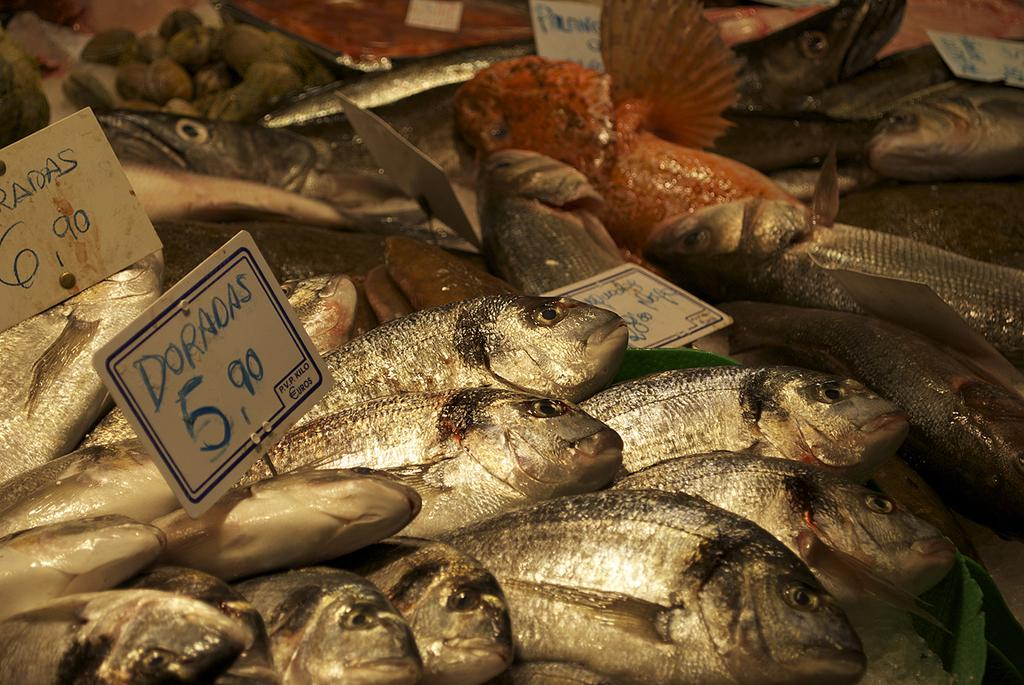What is located in the foreground of the image? There are fish and price tags in the foreground of the image. What type of items might the price tags be associated with? The price tags could be associated with the fish, indicating that they are for sale. What is suggested to be at the top of the image? It appears to be food at the top of the image. Can you describe the girl riding a bike in the image? There is no girl or bike present in the image. 